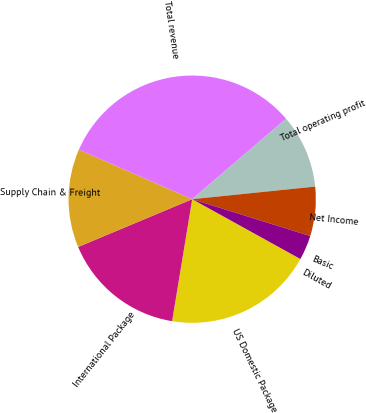Convert chart. <chart><loc_0><loc_0><loc_500><loc_500><pie_chart><fcel>US Domestic Package<fcel>International Package<fcel>Supply Chain & Freight<fcel>Total revenue<fcel>Total operating profit<fcel>Net Income<fcel>Basic<fcel>Diluted<nl><fcel>19.56%<fcel>16.09%<fcel>12.87%<fcel>32.17%<fcel>9.65%<fcel>6.44%<fcel>3.22%<fcel>0.0%<nl></chart> 